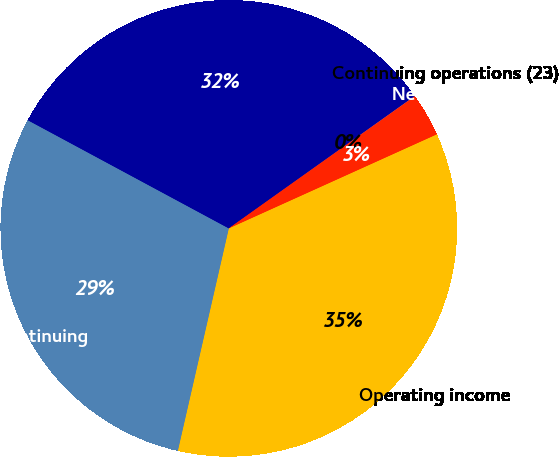Convert chart. <chart><loc_0><loc_0><loc_500><loc_500><pie_chart><fcel>Operating income<fcel>Income from continuing<fcel>Net income<fcel>Continuing operations (23)<fcel>Net income (23)<nl><fcel>35.34%<fcel>29.27%<fcel>32.3%<fcel>0.02%<fcel>3.06%<nl></chart> 